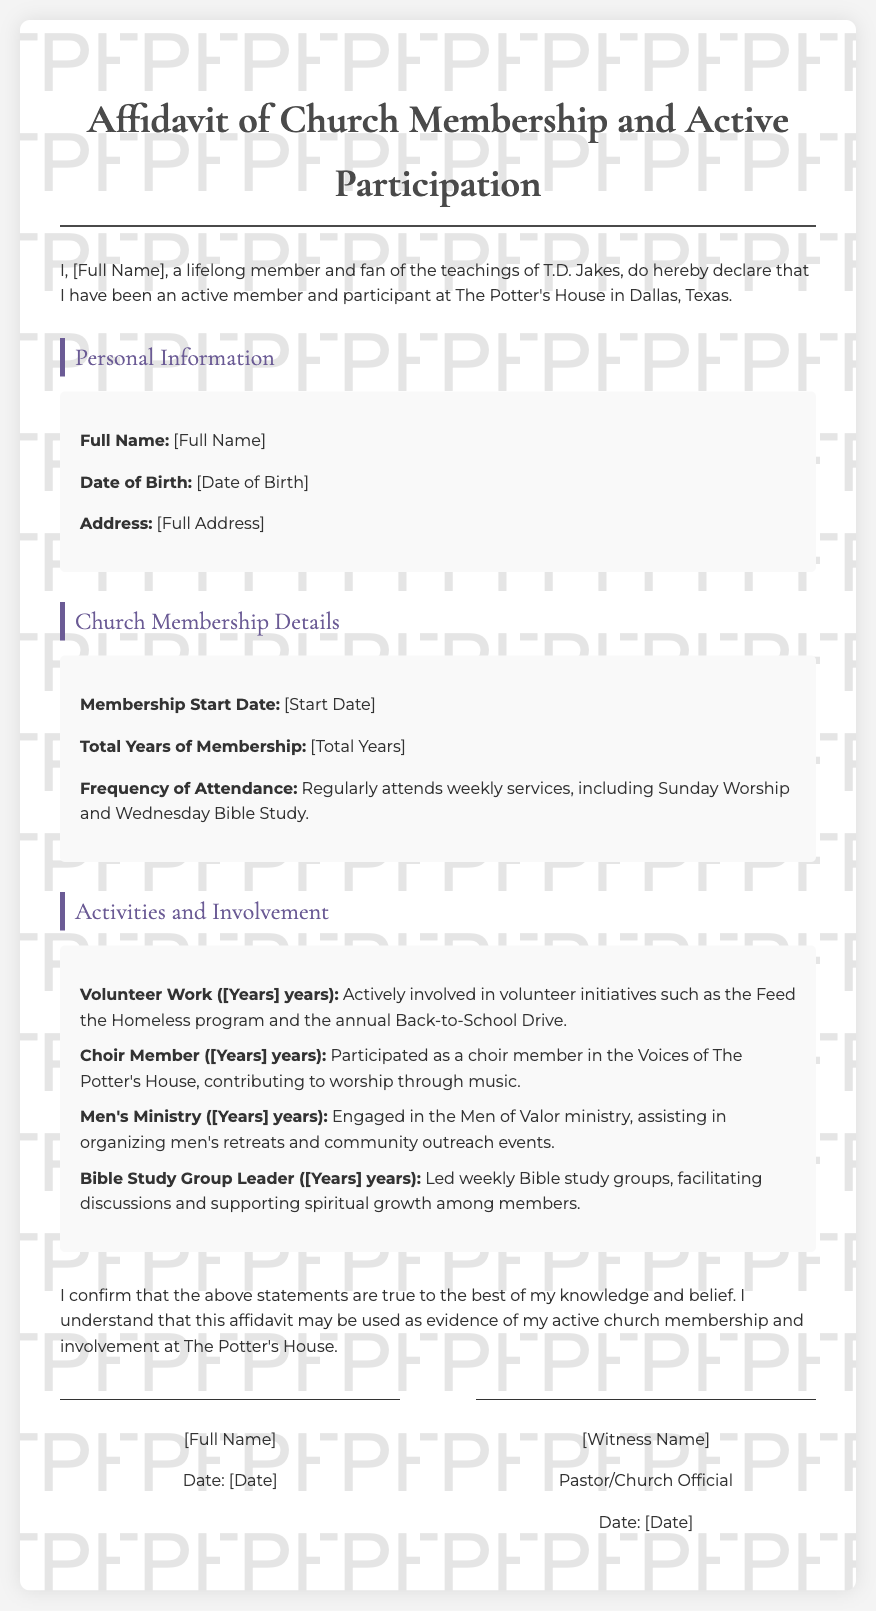what is the full name of the declarant? The full name is listed at the beginning of the affidavit as [Full Name].
Answer: [Full Name] what is the date of birth of the declarant? The date of birth is specified in the personal information section as [Date of Birth].
Answer: [Date of Birth] when did the membership start? The membership start date is indicated in the church membership details as [Start Date].
Answer: [Start Date] how many total years of membership are stated? The total years of membership is provided in the document as [Total Years].
Answer: [Total Years] what are the frequencies of attendance mentioned? The document specifies that the declarant regularly attends weekly services, including Sunday Worship and Wednesday Bible Study.
Answer: Weekly services how many years was the declarant involved in volunteer work? The document states the number of years involved in volunteer work as [Years].
Answer: [Years] which ministry did the declarant participate in for community outreach? The document mentions the Men of Valor ministry as the ministry for community outreach.
Answer: Men of Valor who is the witness for this affidavit? The document notes the witness as [Witness Name].
Answer: [Witness Name] what does the declarant confirm about the statements in the affidavit? The declarant confirms that the statements in the affidavit are true to the best of their knowledge and belief.
Answer: True to the best of my knowledge 